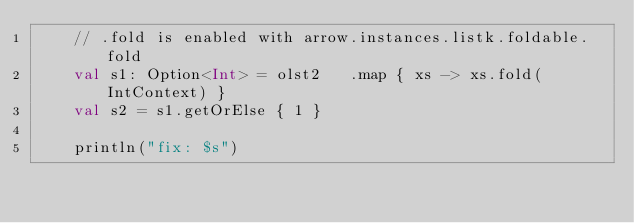<code> <loc_0><loc_0><loc_500><loc_500><_Kotlin_>    // .fold is enabled with arrow.instances.listk.foldable.fold
    val s1: Option<Int> = olst2   .map { xs -> xs.fold(IntContext) }
    val s2 = s1.getOrElse { 1 }

    println("fix: $s")</code> 